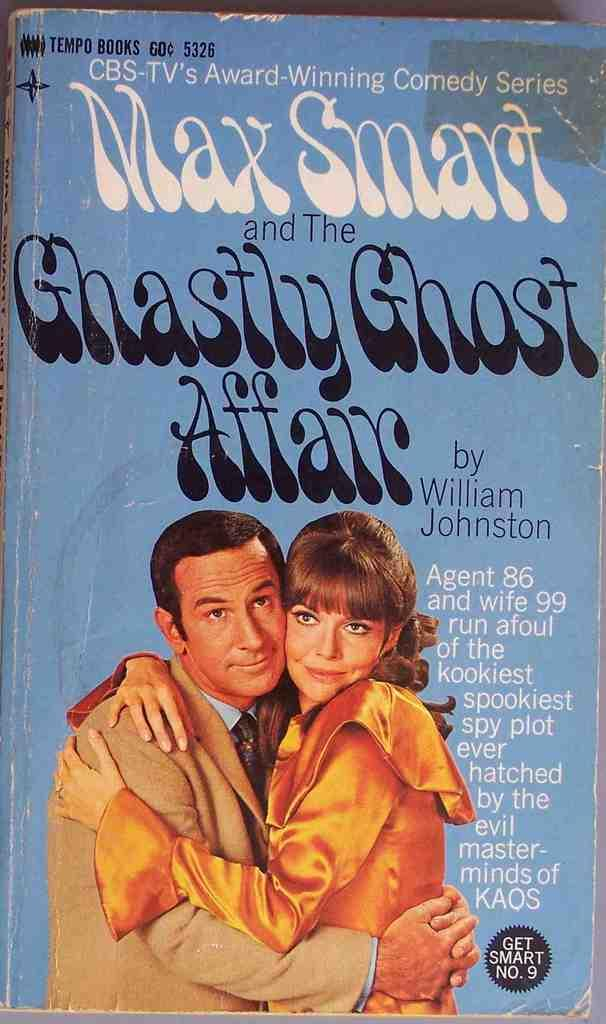<image>
Create a compact narrative representing the image presented. A book with a man and woman hugging on the cover written by William Johnston. 